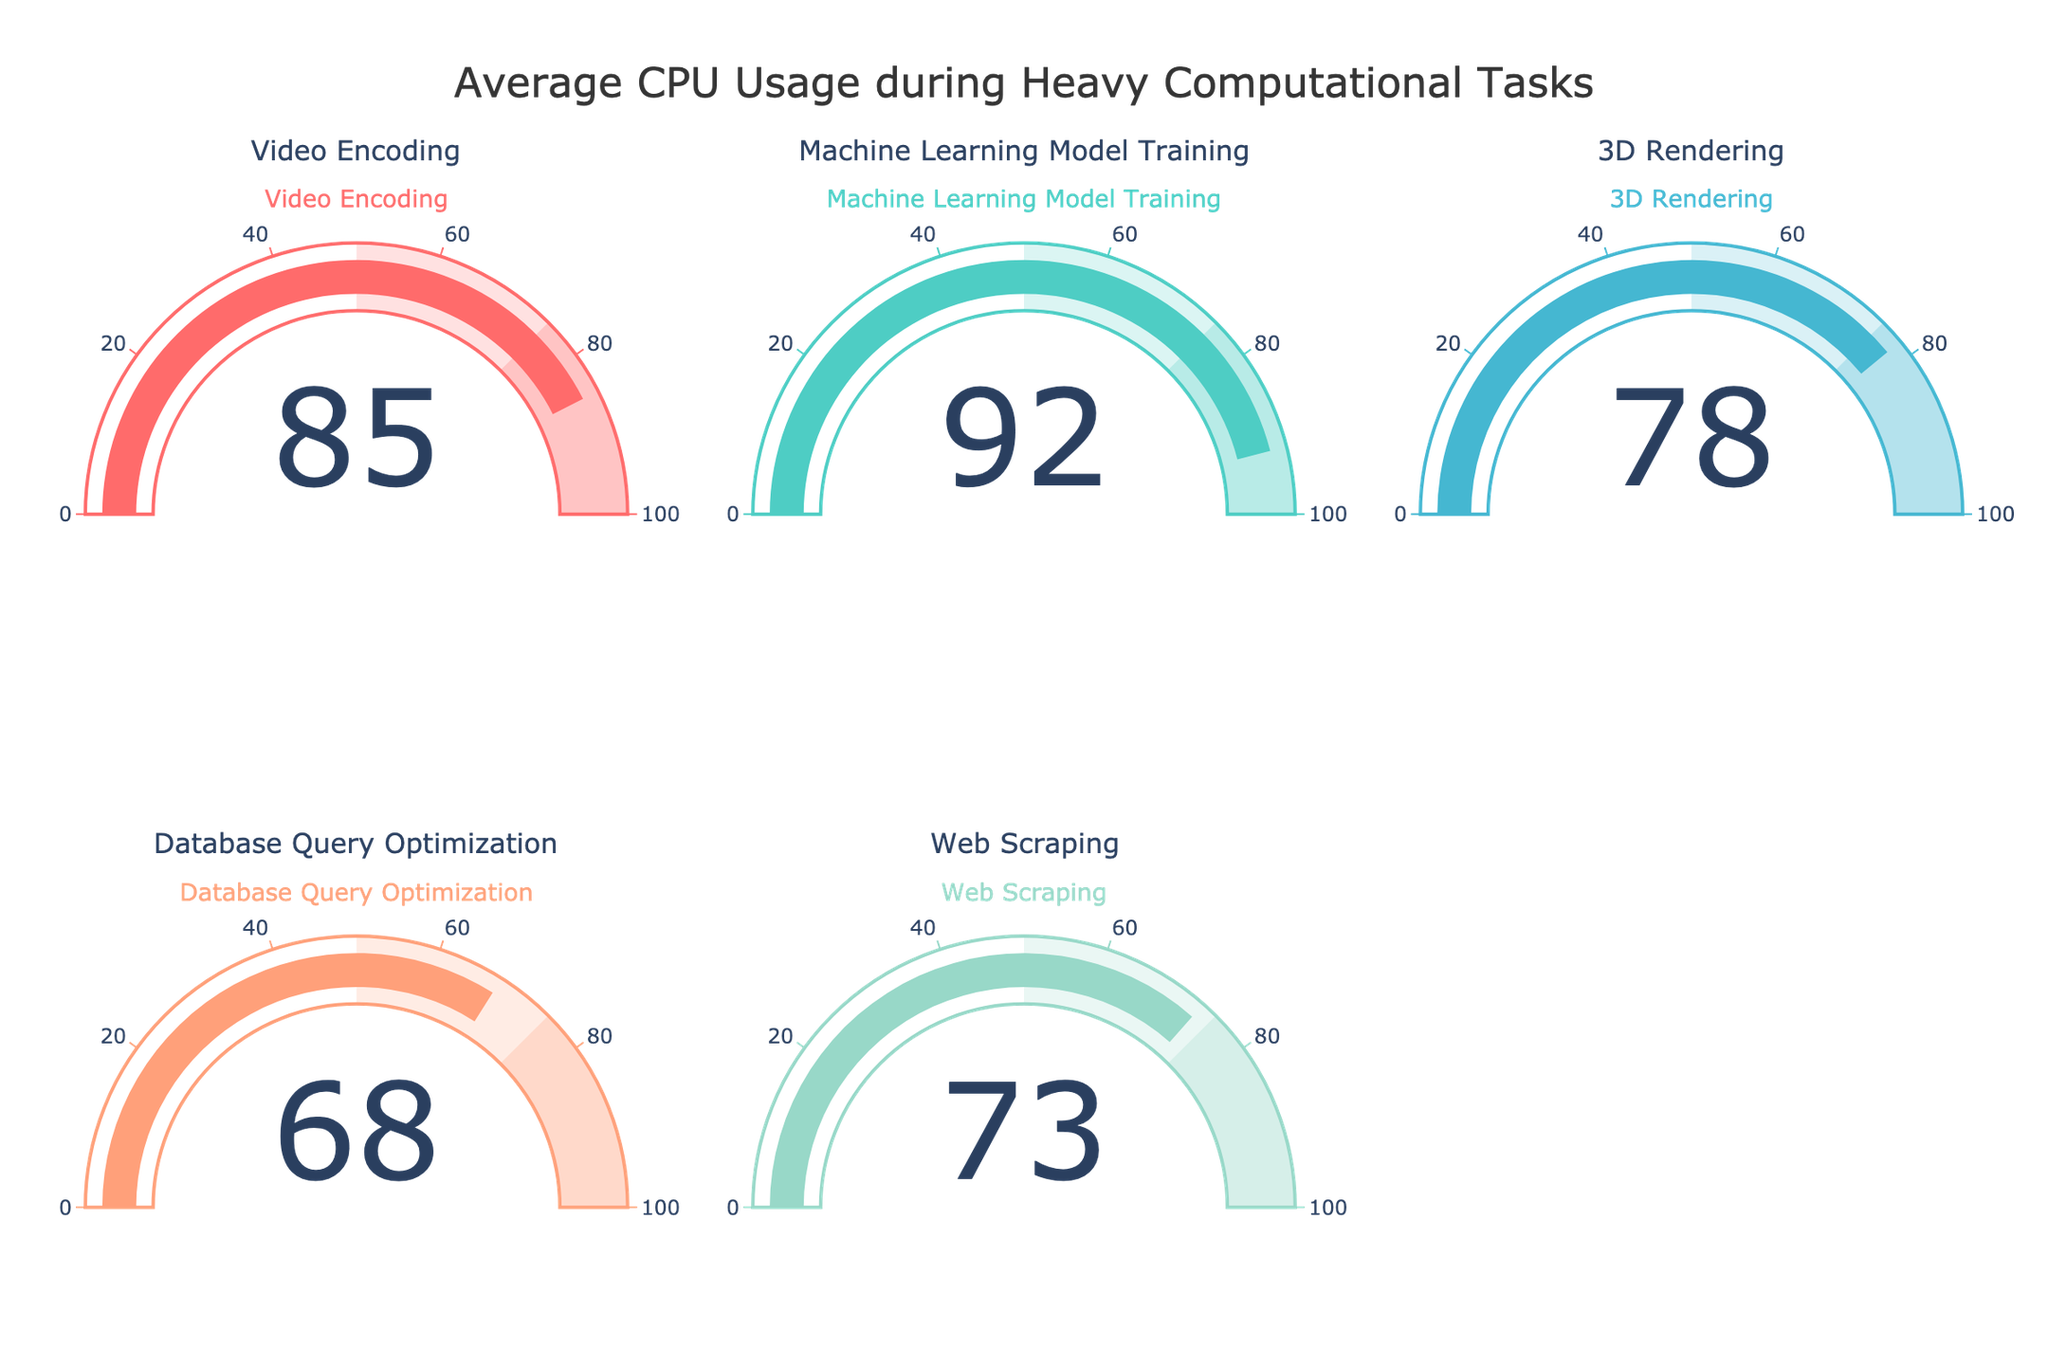What is the average CPU usage during Video Encoding? The gauge chart for Video Encoding shows a CPU usage value. By looking directly at the gauge, we see the number displayed is 85.
Answer: 85 What task has the highest average CPU usage? Each gauge chart displays CPU usage for different tasks. By comparing these numbers, the highest value is for Machine Learning Model Training with a CPU usage of 92.
Answer: Machine Learning Model Training Which task has the lowest CPU usage? Looking at all the values on the gauge charts, Database Query Optimization shows the lowest CPU usage with 68.
Answer: Database Query Optimization Compare the CPU usage between Video Encoding and 3D Rendering. Which task uses more CPU? The gauge chart for Video Encoding shows 85 and for 3D Rendering it shows 78. Since 85 is greater than 78, Video Encoding uses more CPU.
Answer: Video Encoding What is the difference in CPU usage between Web Scraping and Database Query Optimization? Web Scraping has a CPU usage of 73 and Database Query Optimization has 68. The difference between them is 73 - 68 = 5.
Answer: 5 Which tasks have a CPU usage greater than 75? By looking at the gauge charts, we can see that Video Encoding (85), Machine Learning Model Training (92), and 3D Rendering (78) all have values greater than 75.
Answer: Video Encoding, Machine Learning Model Training, 3D Rendering What is the average CPU usage across all tasks displayed? The CPU usages shown on the gauge charts are 85, 92, 78, 68, and 73. The mean is calculated by summing these values and dividing by the number of tasks: (85 + 92 + 78 + 68 + 73) / 5 = 396 / 5 = 79.2.
Answer: 79.2 What is the range of CPU usage across all tasks? The range is found by subtracting the smallest value from the largest value. The highest usage is 92 (Machine Learning Model Training) and the lowest is 68 (Database Query Optimization). So, 92 - 68 = 24.
Answer: 24 